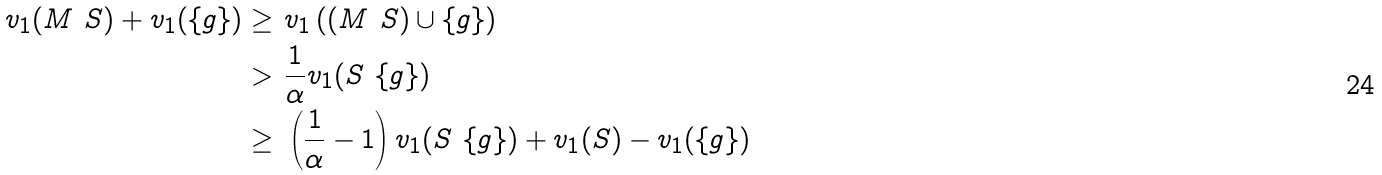<formula> <loc_0><loc_0><loc_500><loc_500>v _ { 1 } ( M \ S ) + v _ { 1 } ( \{ g \} ) \geq & \ v _ { 1 } \left ( ( M \ S ) \cup \{ g \} \right ) \\ > & \ \frac { 1 } { \alpha } v _ { 1 } ( S \ \{ g \} ) \\ \geq & \ \left ( \frac { 1 } { \alpha } - 1 \right ) v _ { 1 } ( S \ \{ g \} ) + v _ { 1 } ( S ) - v _ { 1 } ( \{ g \} )</formula> 